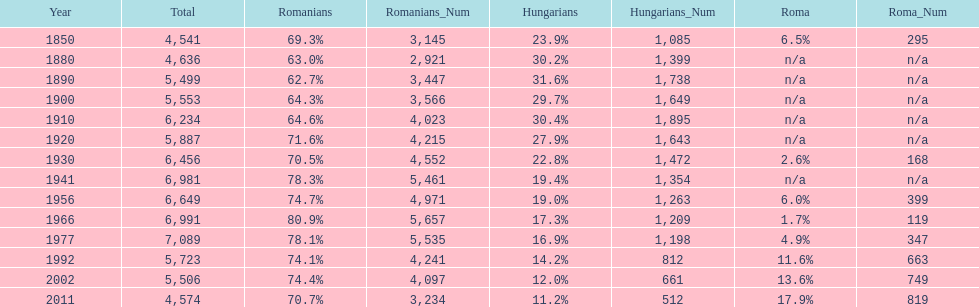What is the number of times the total population was 6,000 or more? 6. 